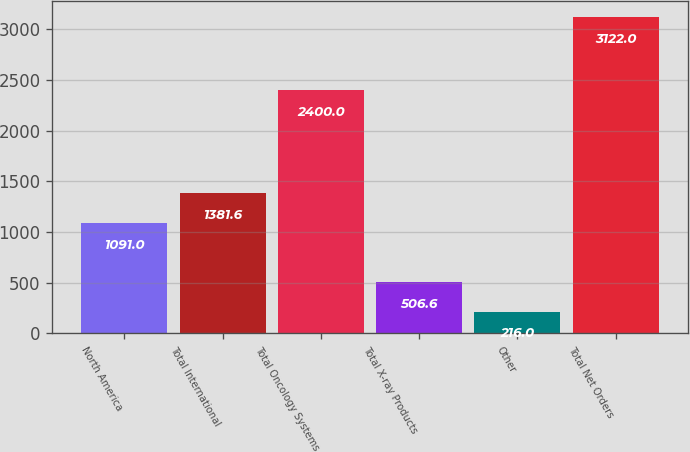Convert chart to OTSL. <chart><loc_0><loc_0><loc_500><loc_500><bar_chart><fcel>North America<fcel>Total International<fcel>Total Oncology Systems<fcel>Total X-ray Products<fcel>Other<fcel>Total Net Orders<nl><fcel>1091<fcel>1381.6<fcel>2400<fcel>506.6<fcel>216<fcel>3122<nl></chart> 